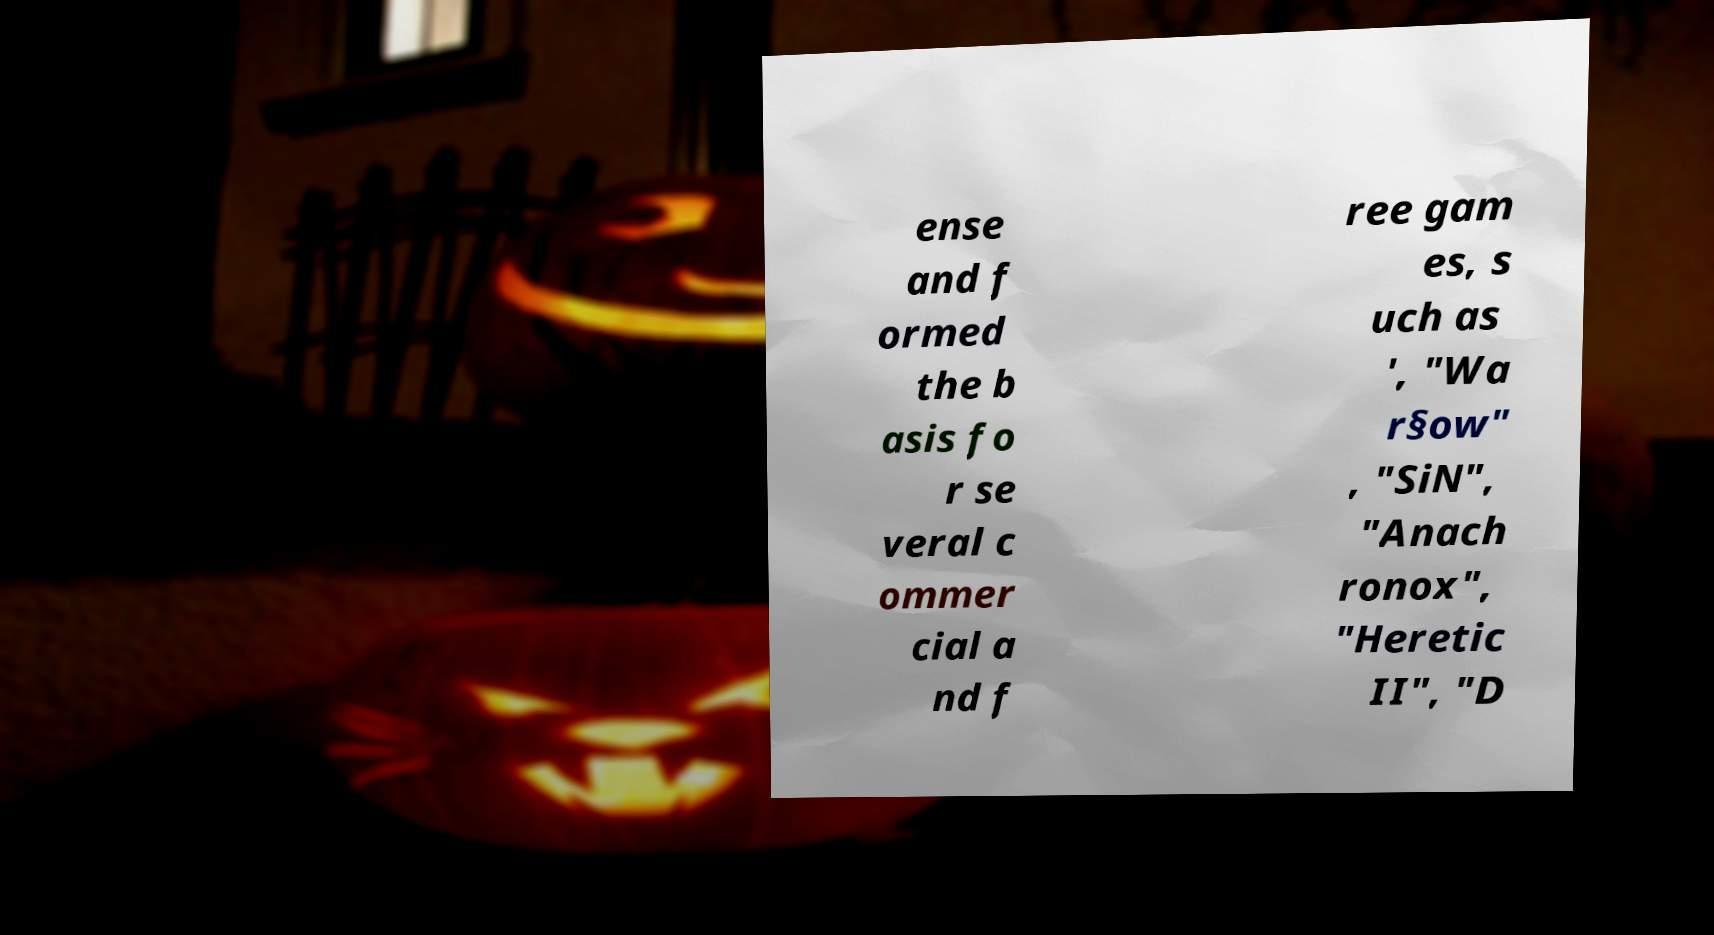Please identify and transcribe the text found in this image. ense and f ormed the b asis fo r se veral c ommer cial a nd f ree gam es, s uch as ', "Wa r§ow" , "SiN", "Anach ronox", "Heretic II", "D 